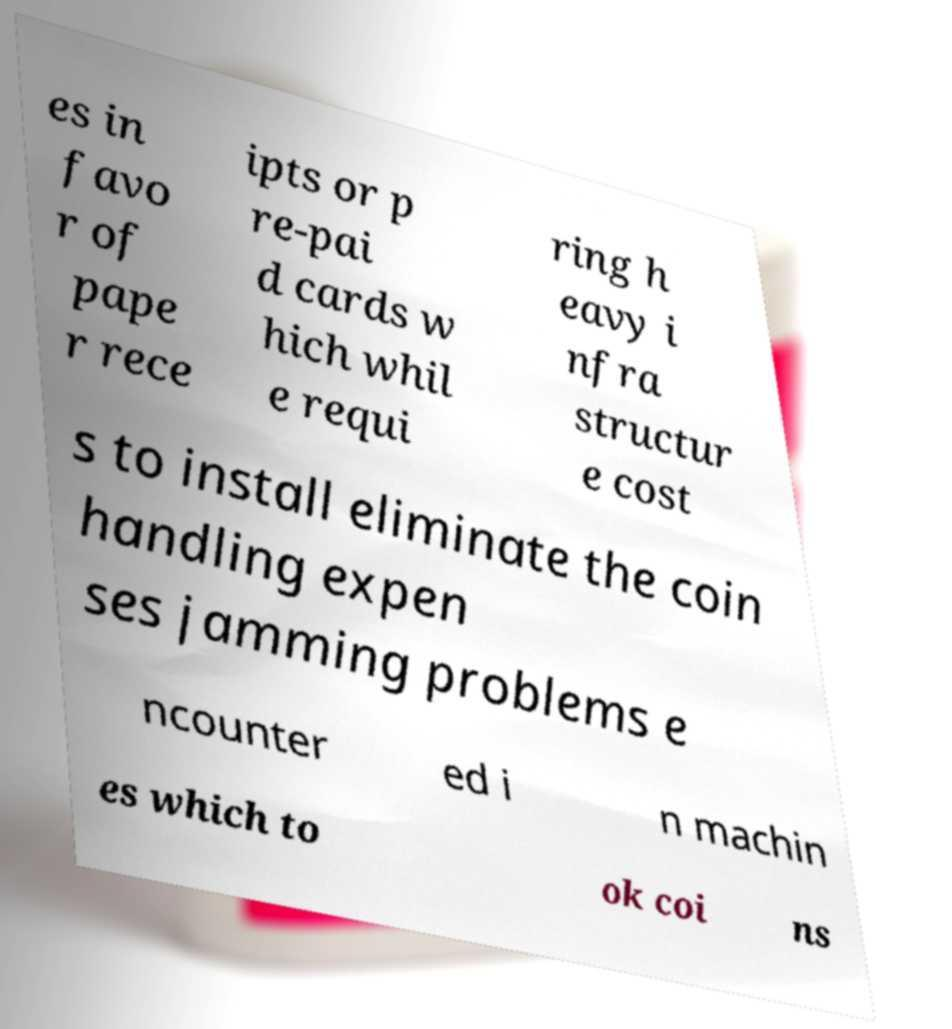Could you assist in decoding the text presented in this image and type it out clearly? es in favo r of pape r rece ipts or p re-pai d cards w hich whil e requi ring h eavy i nfra structur e cost s to install eliminate the coin handling expen ses jamming problems e ncounter ed i n machin es which to ok coi ns 